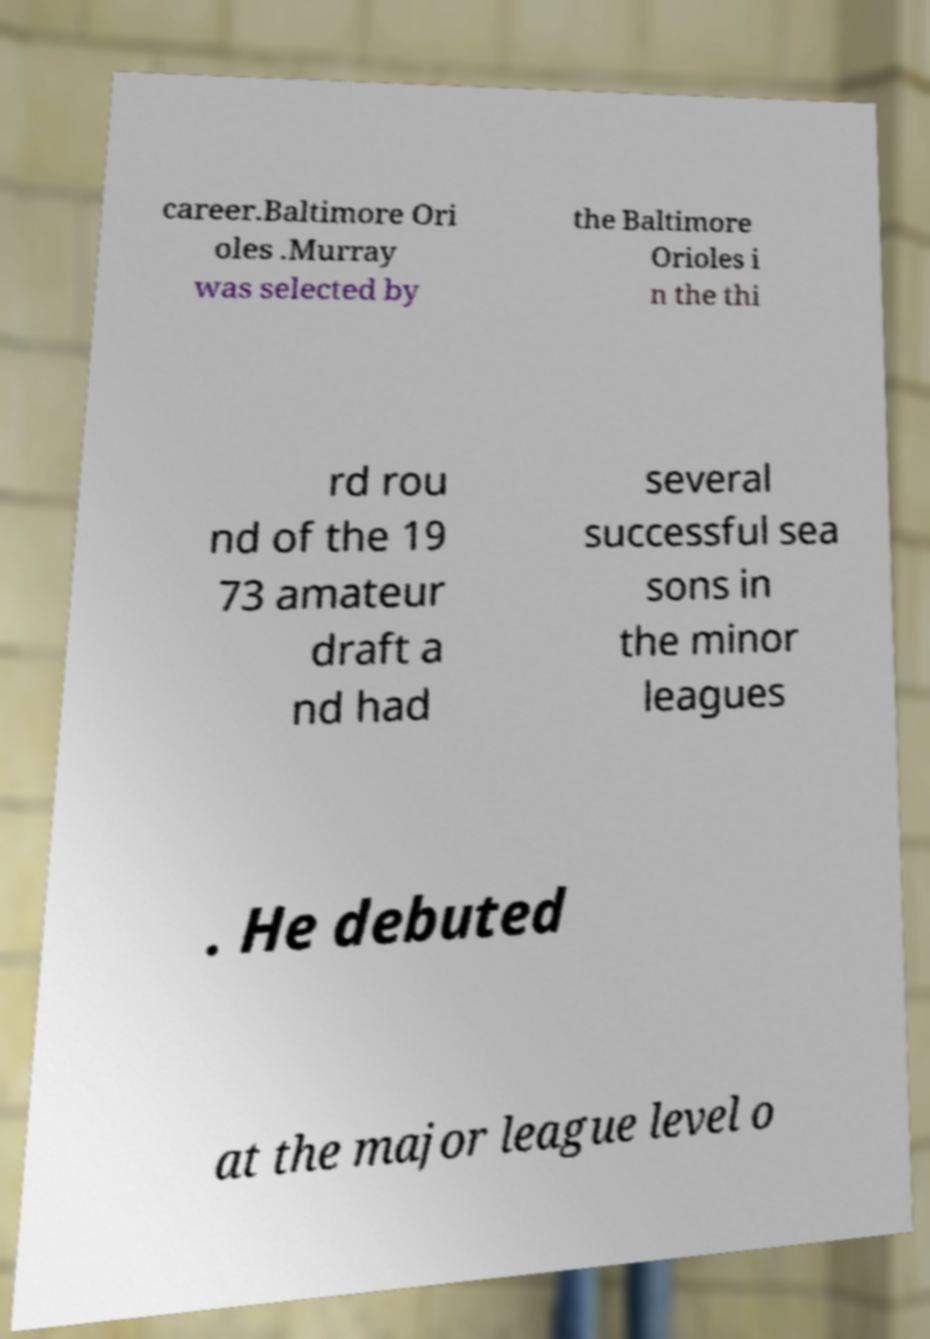I need the written content from this picture converted into text. Can you do that? career.Baltimore Ori oles .Murray was selected by the Baltimore Orioles i n the thi rd rou nd of the 19 73 amateur draft a nd had several successful sea sons in the minor leagues . He debuted at the major league level o 